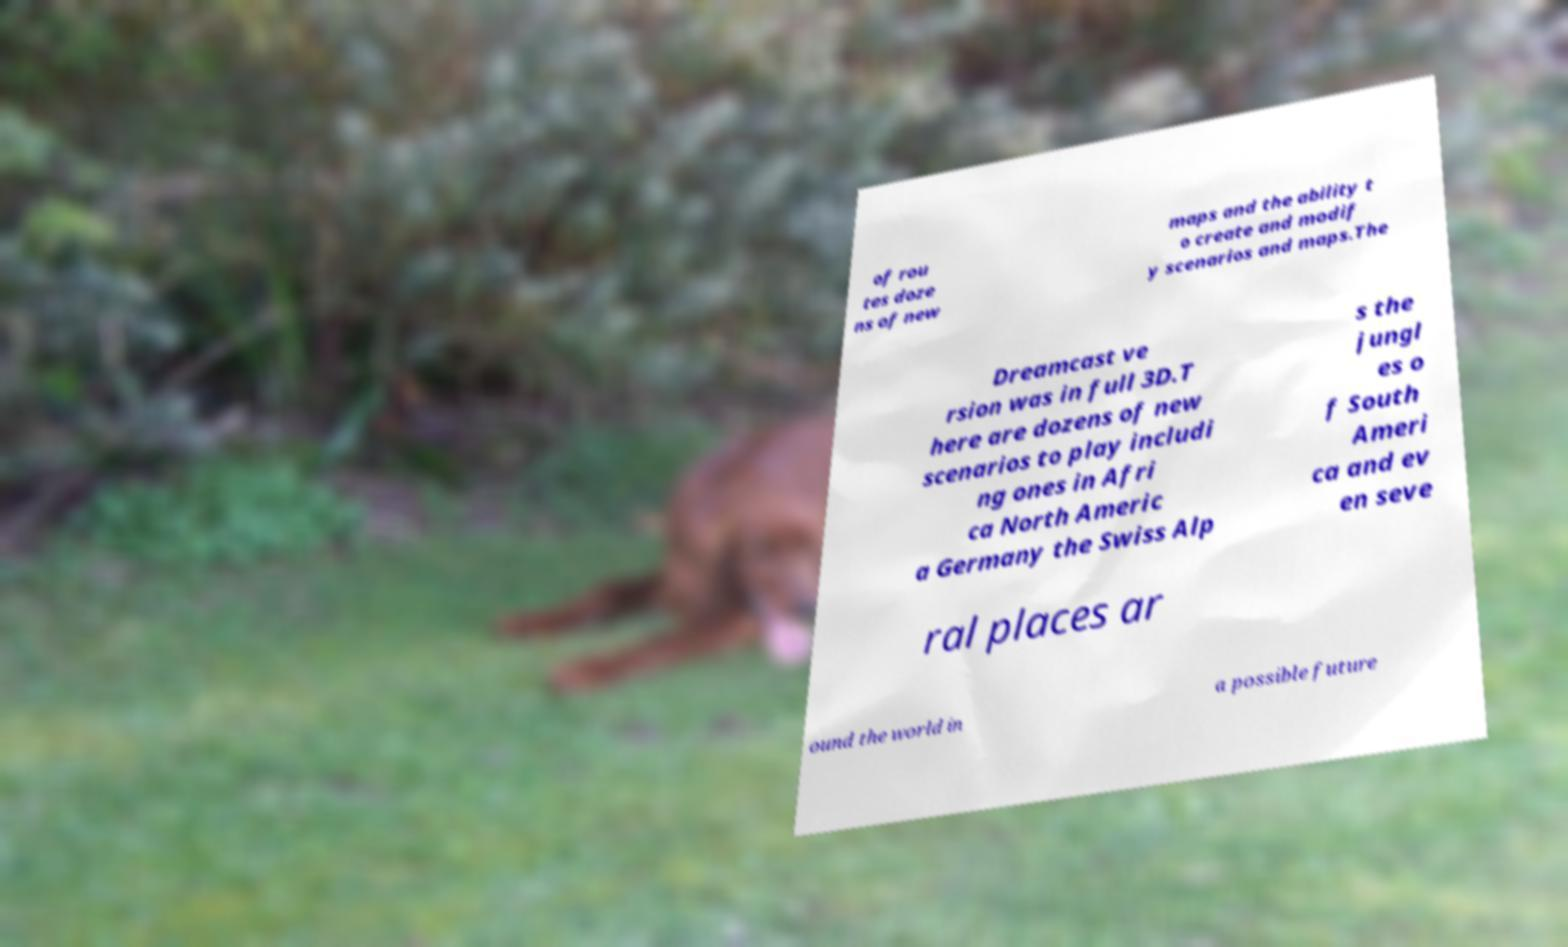Can you accurately transcribe the text from the provided image for me? of rou tes doze ns of new maps and the ability t o create and modif y scenarios and maps.The Dreamcast ve rsion was in full 3D.T here are dozens of new scenarios to play includi ng ones in Afri ca North Americ a Germany the Swiss Alp s the jungl es o f South Ameri ca and ev en seve ral places ar ound the world in a possible future 